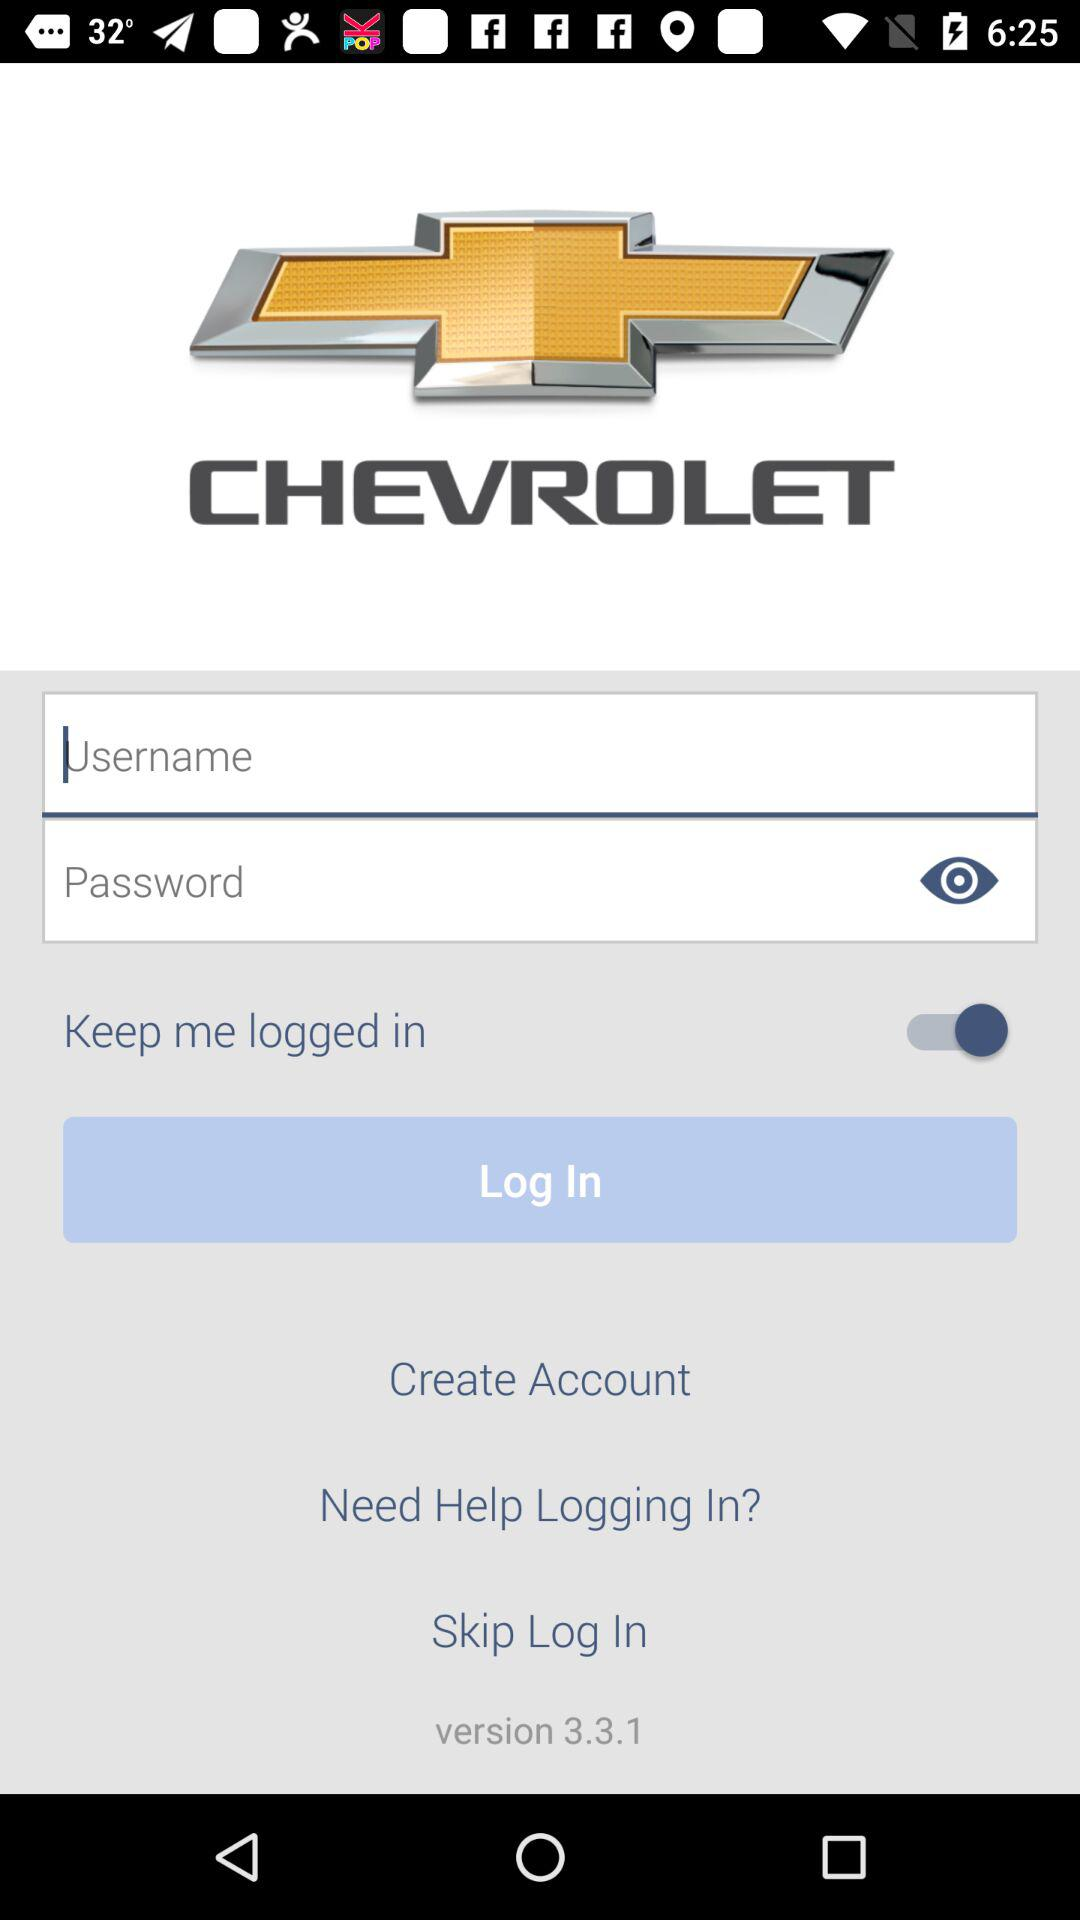What is the status of "Keep me logged in"? The status is "on". 